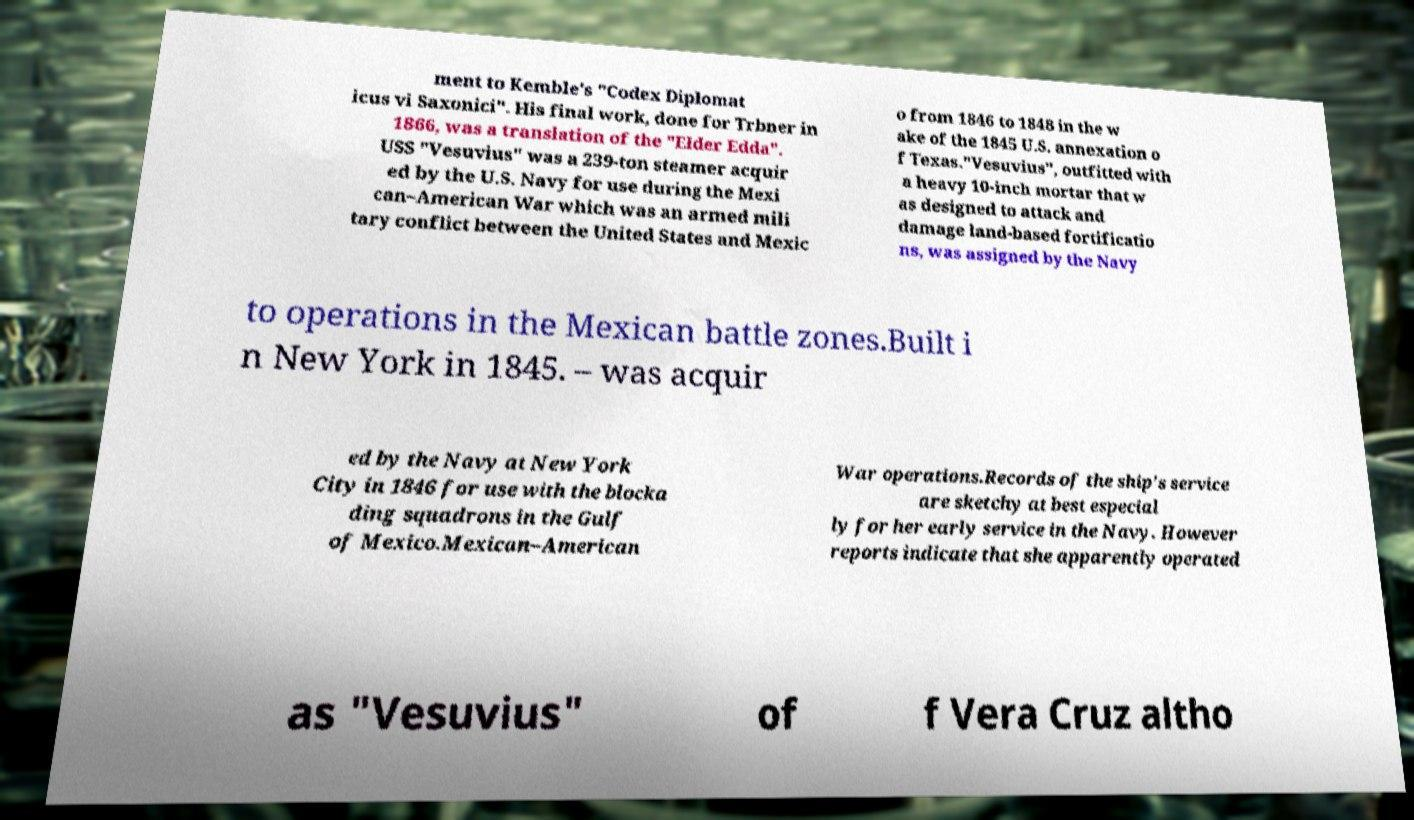What messages or text are displayed in this image? I need them in a readable, typed format. ment to Kemble's "Codex Diplomat icus vi Saxonici". His final work, done for Trbner in 1866, was a translation of the "Elder Edda". USS "Vesuvius" was a 239-ton steamer acquir ed by the U.S. Navy for use during the Mexi can–American War which was an armed mili tary conflict between the United States and Mexic o from 1846 to 1848 in the w ake of the 1845 U.S. annexation o f Texas."Vesuvius", outfitted with a heavy 10-inch mortar that w as designed to attack and damage land-based fortificatio ns, was assigned by the Navy to operations in the Mexican battle zones.Built i n New York in 1845. – was acquir ed by the Navy at New York City in 1846 for use with the blocka ding squadrons in the Gulf of Mexico.Mexican–American War operations.Records of the ship's service are sketchy at best especial ly for her early service in the Navy. However reports indicate that she apparently operated as "Vesuvius" of f Vera Cruz altho 